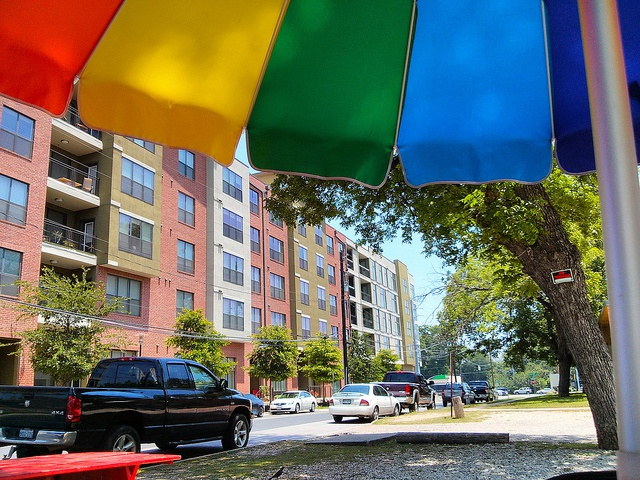Describe the objects in this image and their specific colors. I can see umbrella in red, darkgreen, blue, and orange tones, truck in brown, black, navy, gray, and blue tones, dining table in brown, salmon, red, and maroon tones, car in brown, white, darkgray, black, and lightblue tones, and truck in brown, black, navy, gray, and darkgray tones in this image. 